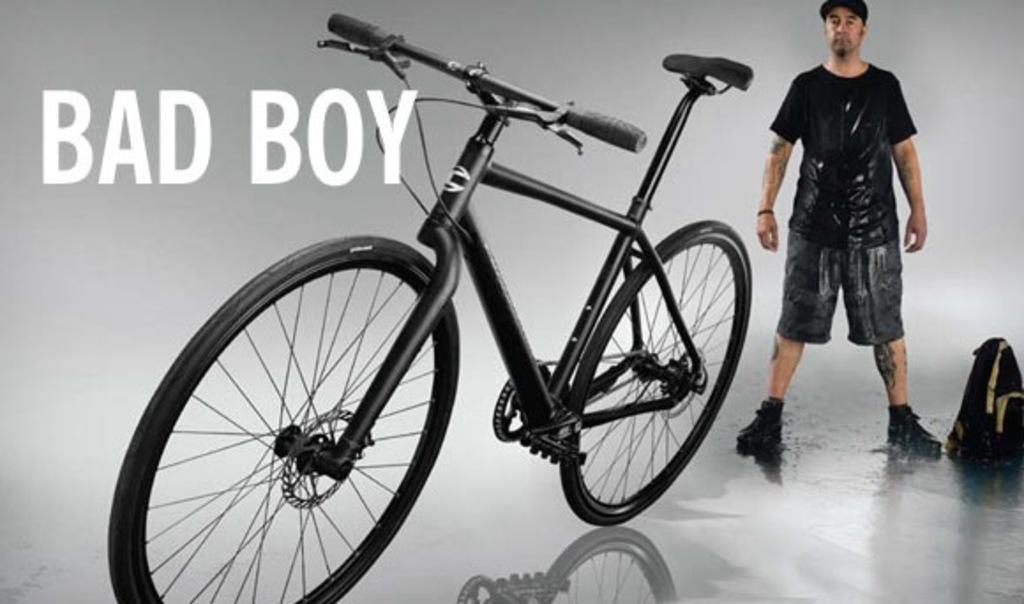How would you summarize this image in a sentence or two? In this image we can see a black color bicycle and a man is standing, he is wearing black color t-shirt. Right side of the image one bag is there and on the image a watermark is present. 